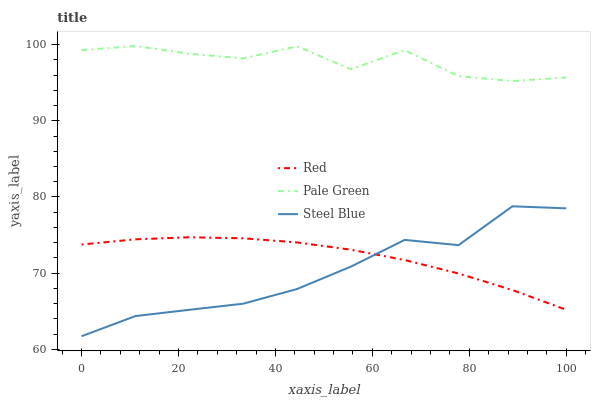Does Red have the minimum area under the curve?
Answer yes or no. No. Does Red have the maximum area under the curve?
Answer yes or no. No. Is Steel Blue the smoothest?
Answer yes or no. No. Is Steel Blue the roughest?
Answer yes or no. No. Does Red have the lowest value?
Answer yes or no. No. Does Steel Blue have the highest value?
Answer yes or no. No. Is Red less than Pale Green?
Answer yes or no. Yes. Is Pale Green greater than Steel Blue?
Answer yes or no. Yes. Does Red intersect Pale Green?
Answer yes or no. No. 